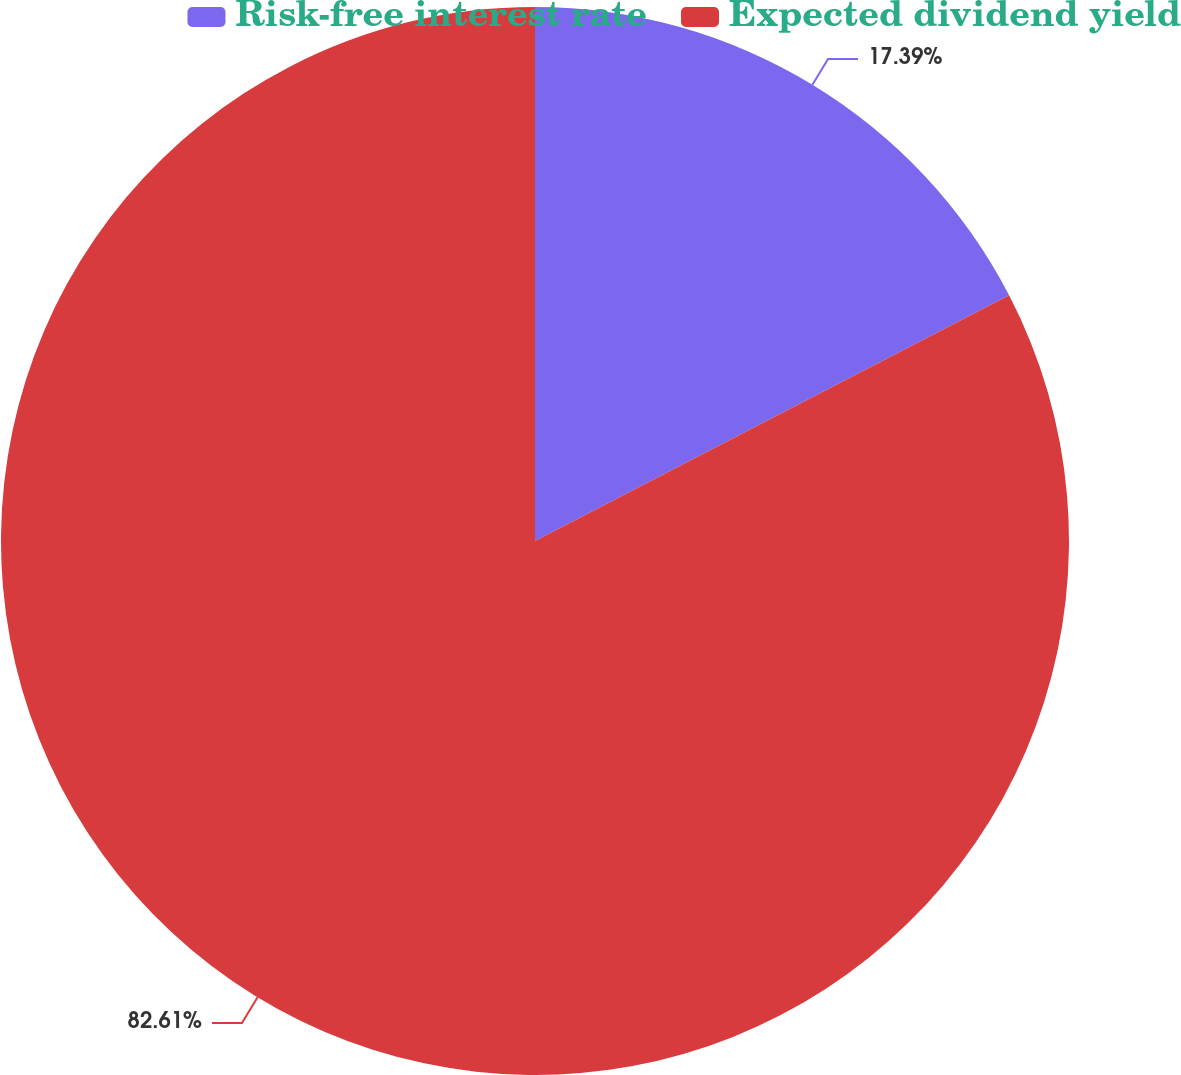<chart> <loc_0><loc_0><loc_500><loc_500><pie_chart><fcel>Risk-free interest rate<fcel>Expected dividend yield<nl><fcel>17.39%<fcel>82.61%<nl></chart> 